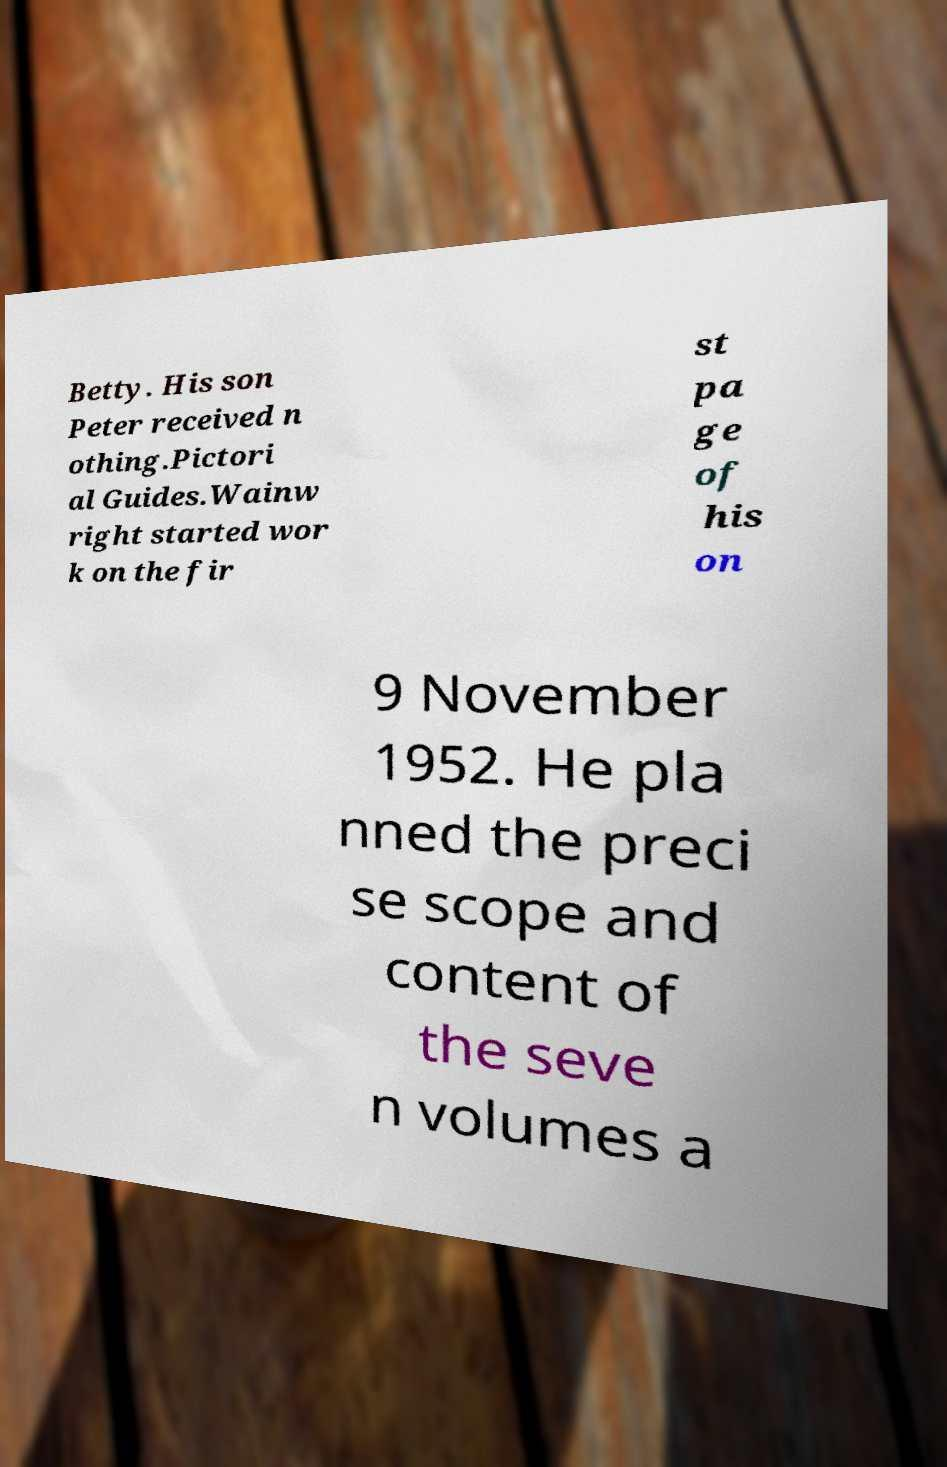There's text embedded in this image that I need extracted. Can you transcribe it verbatim? Betty. His son Peter received n othing.Pictori al Guides.Wainw right started wor k on the fir st pa ge of his on 9 November 1952. He pla nned the preci se scope and content of the seve n volumes a 